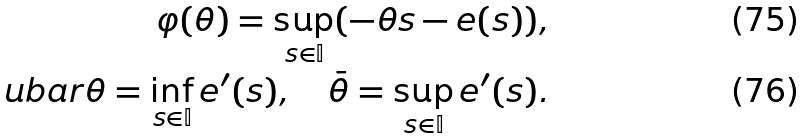Convert formula to latex. <formula><loc_0><loc_0><loc_500><loc_500>\varphi ( \theta ) = \sup _ { s \in { \mathbb { I } } } ( - \theta s - e ( s ) ) , \\ \ u b a r \theta = \inf _ { s \in { \mathbb { I } } } e ^ { \prime } ( s ) , \quad \bar { \theta } = \sup _ { s \in { \mathbb { I } } } e ^ { \prime } ( s ) .</formula> 